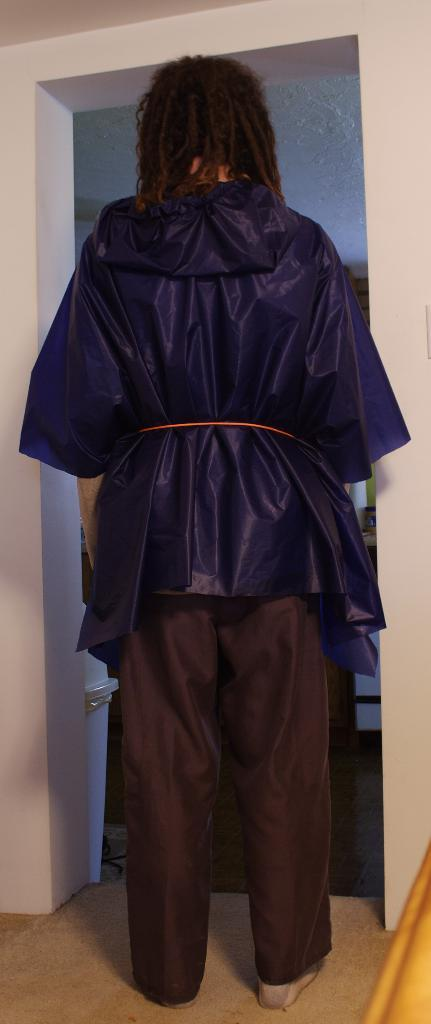Who or what is present in the image? There is a person in the image. What is the person wearing on their upper body? The person is wearing a blue color hoodie. What is the person wearing on their lower body? The person is wearing brown color pants. What surface is the person standing on? The person is standing on the floor. What can be seen behind the person in the image? There is a white color wall in the background of the image. What type of pump can be seen in the image? There is no pump present in the image. Is the queen mentioned or depicted in the image? No, the queen is not mentioned or depicted in the image. 